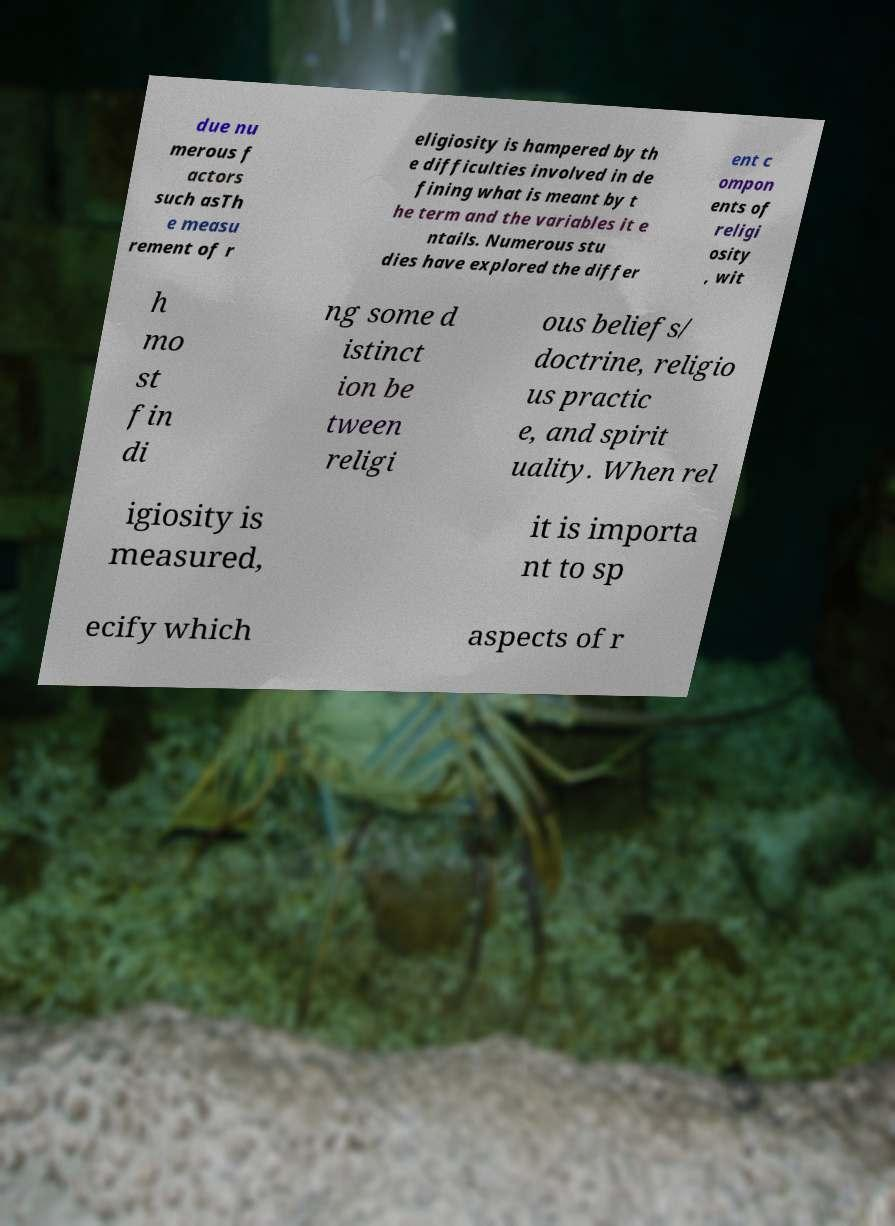There's text embedded in this image that I need extracted. Can you transcribe it verbatim? due nu merous f actors such asTh e measu rement of r eligiosity is hampered by th e difficulties involved in de fining what is meant by t he term and the variables it e ntails. Numerous stu dies have explored the differ ent c ompon ents of religi osity , wit h mo st fin di ng some d istinct ion be tween religi ous beliefs/ doctrine, religio us practic e, and spirit uality. When rel igiosity is measured, it is importa nt to sp ecify which aspects of r 